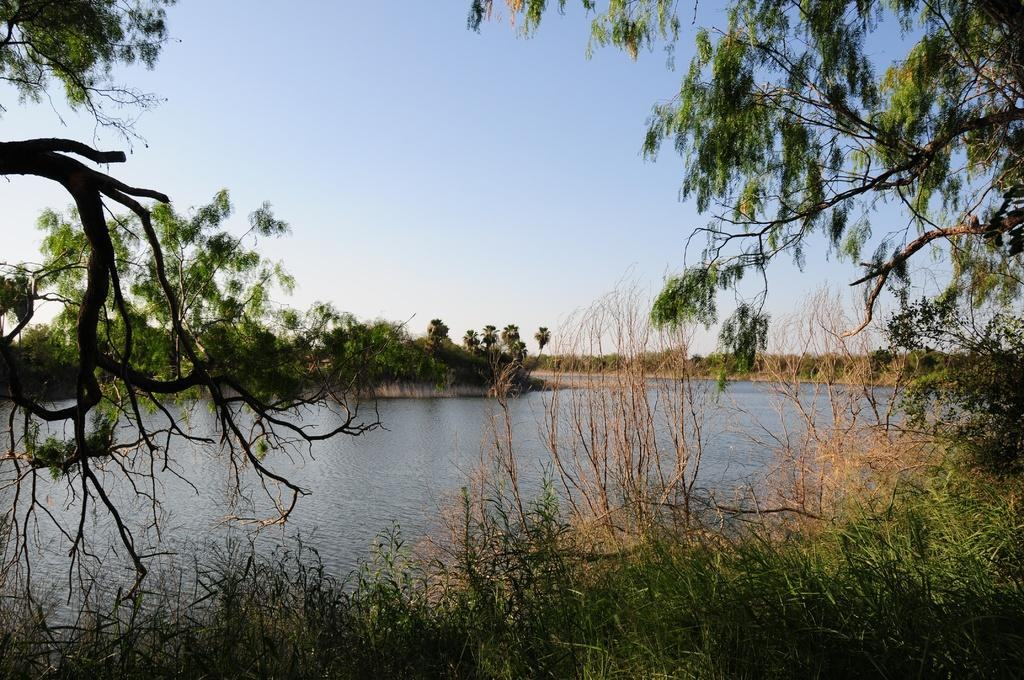What can be seen in the image? There is water visible in the image, and there are trees present as well. Can you describe the water in the image? The water is visible, but its specific characteristics are not mentioned in the facts provided. What type of vegetation is in the image? The trees in the image are the type of vegetation mentioned. How many servants are attending to the quince in the image? There is no mention of a quince or servants in the image, so this question cannot be answered. 